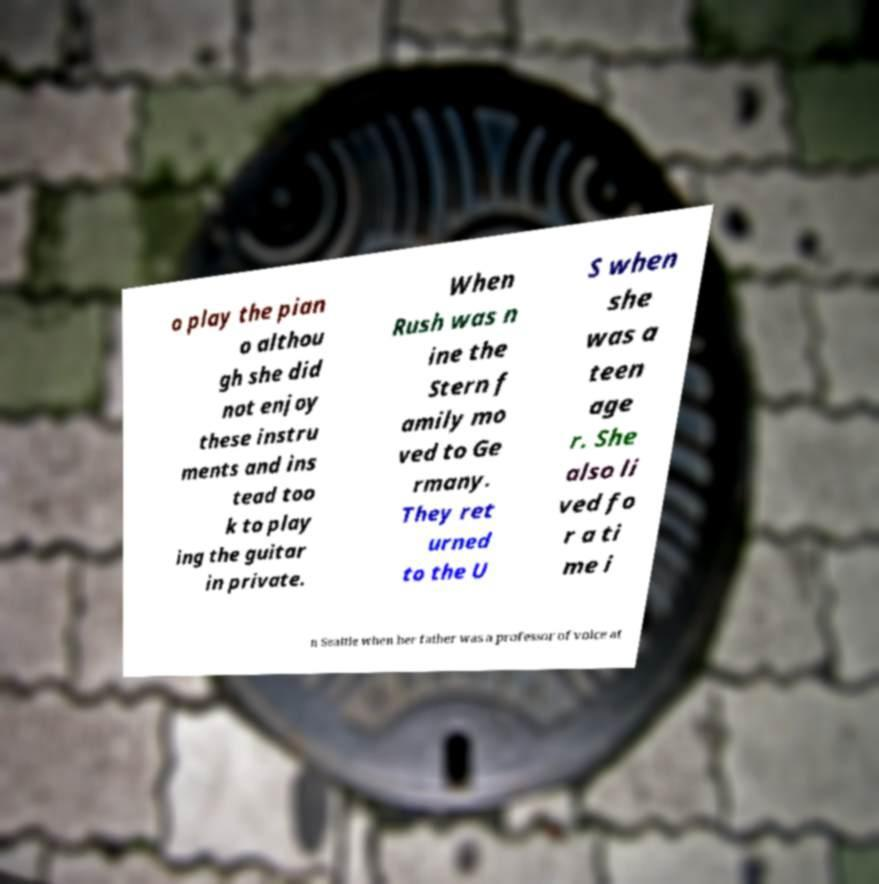I need the written content from this picture converted into text. Can you do that? o play the pian o althou gh she did not enjoy these instru ments and ins tead too k to play ing the guitar in private. When Rush was n ine the Stern f amily mo ved to Ge rmany. They ret urned to the U S when she was a teen age r. She also li ved fo r a ti me i n Seattle when her father was a professor of voice at 